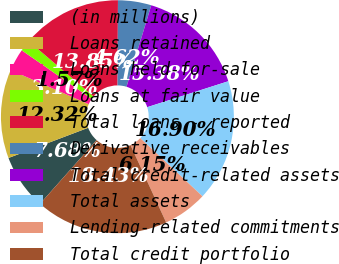Convert chart to OTSL. <chart><loc_0><loc_0><loc_500><loc_500><pie_chart><fcel>(in millions)<fcel>Loans retained<fcel>Loans held-for-sale<fcel>Loans at fair value<fcel>Total loans - reported<fcel>Derivative receivables<fcel>Total credit-related assets<fcel>Total assets<fcel>Lending-related commitments<fcel>Total credit portfolio<nl><fcel>7.68%<fcel>12.32%<fcel>3.1%<fcel>1.57%<fcel>13.85%<fcel>4.62%<fcel>15.38%<fcel>16.9%<fcel>6.15%<fcel>18.43%<nl></chart> 